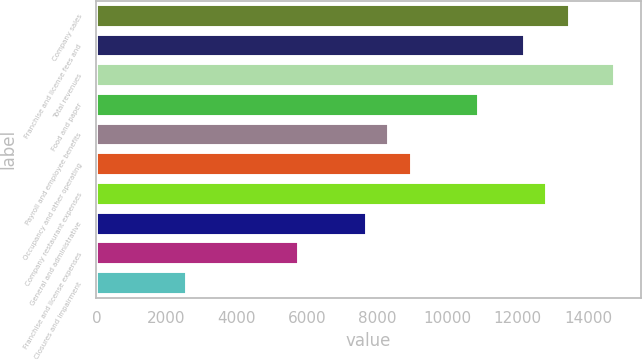<chart> <loc_0><loc_0><loc_500><loc_500><bar_chart><fcel>Company sales<fcel>Franchise and license fees and<fcel>Total revenues<fcel>Food and paper<fcel>Payroll and employee benefits<fcel>Occupancy and other operating<fcel>Company restaurant expenses<fcel>General and administrative<fcel>Franchise and license expenses<fcel>Closures and impairment<nl><fcel>13476<fcel>12192.7<fcel>14759.2<fcel>10909.5<fcel>8342.93<fcel>8984.56<fcel>12834.3<fcel>7701.3<fcel>5776.41<fcel>2568.26<nl></chart> 